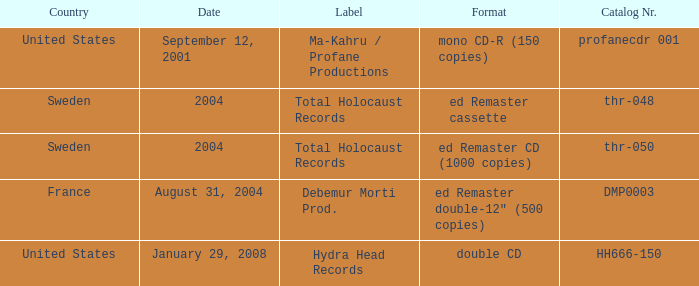What date features total holocaust records in the ed remaster audio tape format? 2004.0. Can you parse all the data within this table? {'header': ['Country', 'Date', 'Label', 'Format', 'Catalog Nr.'], 'rows': [['United States', 'September 12, 2001', 'Ma-Kahru / Profane Productions', 'mono CD-R (150 copies)', 'profanecdr 001'], ['Sweden', '2004', 'Total Holocaust Records', 'ed Remaster cassette', 'thr-048'], ['Sweden', '2004', 'Total Holocaust Records', 'ed Remaster CD (1000 copies)', 'thr-050'], ['France', 'August 31, 2004', 'Debemur Morti Prod.', 'ed Remaster double-12" (500 copies)', 'DMP0003'], ['United States', 'January 29, 2008', 'Hydra Head Records', 'double CD', 'HH666-150']]} 